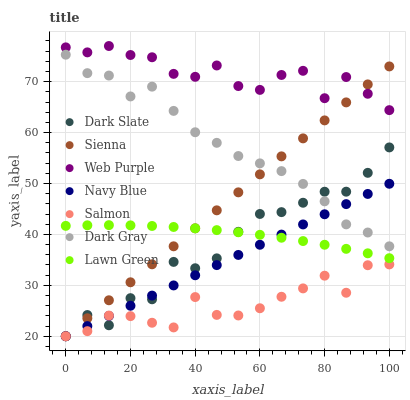Does Salmon have the minimum area under the curve?
Answer yes or no. Yes. Does Web Purple have the maximum area under the curve?
Answer yes or no. Yes. Does Lawn Green have the minimum area under the curve?
Answer yes or no. No. Does Lawn Green have the maximum area under the curve?
Answer yes or no. No. Is Sienna the smoothest?
Answer yes or no. Yes. Is Dark Slate the roughest?
Answer yes or no. Yes. Is Lawn Green the smoothest?
Answer yes or no. No. Is Lawn Green the roughest?
Answer yes or no. No. Does Navy Blue have the lowest value?
Answer yes or no. Yes. Does Lawn Green have the lowest value?
Answer yes or no. No. Does Web Purple have the highest value?
Answer yes or no. Yes. Does Lawn Green have the highest value?
Answer yes or no. No. Is Lawn Green less than Dark Gray?
Answer yes or no. Yes. Is Dark Gray greater than Lawn Green?
Answer yes or no. Yes. Does Navy Blue intersect Dark Slate?
Answer yes or no. Yes. Is Navy Blue less than Dark Slate?
Answer yes or no. No. Is Navy Blue greater than Dark Slate?
Answer yes or no. No. Does Lawn Green intersect Dark Gray?
Answer yes or no. No. 